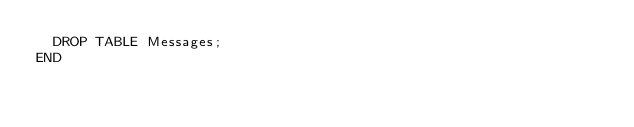<code> <loc_0><loc_0><loc_500><loc_500><_SQL_>	DROP TABLE Messages;
END</code> 